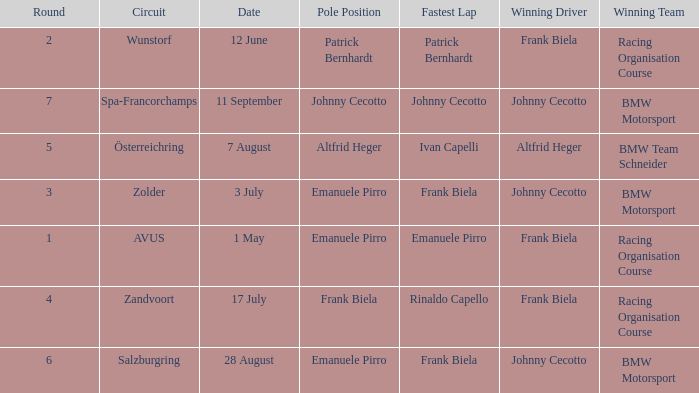Who was the winning team on the circuit Zolder? BMW Motorsport. 